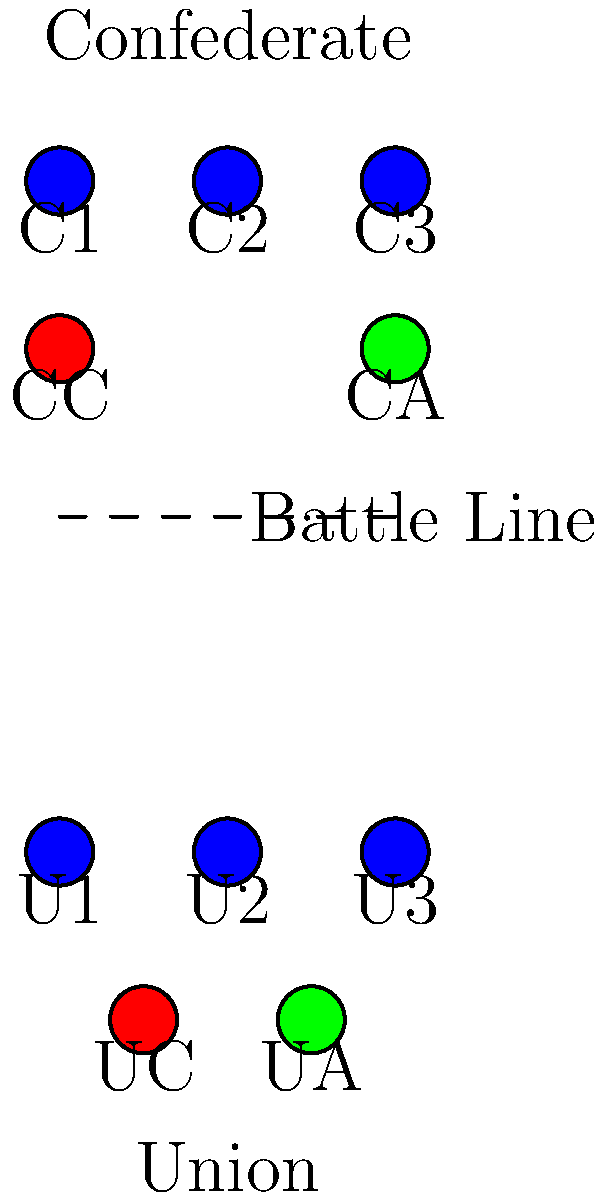In the diagram above, which represents a typical Civil War battle formation, what tactical advantage does the placement of the Union cavalry (UC) provide compared to the Confederate cavalry (CC)? To answer this question, let's analyze the positions of both cavalry units:

1. Union cavalry (UC) placement:
   - Located at the rear of the Union infantry line
   - Positioned between two infantry units (U1 and U2)

2. Confederate cavalry (CC) placement:
   - Located on the left flank of the Confederate infantry line
   - Positioned outside the main line of infantry

3. Tactical advantages of the Union cavalry placement:
   a. Central position: The UC can quickly respond to threats on either flank of the Union line.
   b. Protection: Being behind the infantry line, the UC is less vulnerable to direct attacks.
   c. Flexibility: The UC can be used for counterattacks or to exploit weaknesses in the enemy line.
   d. Support: The UC can provide immediate support to any part of the Union line that needs reinforcement.

4. Limitations of the Confederate cavalry placement:
   a. Limited mobility: The CC is restricted to operations on the left flank.
   b. Vulnerability: Being on the flank, the CC is more exposed to enemy fire and flanking maneuvers.
   c. Reduced ability to support the center and right flank of the Confederate line.

5. Historical context:
   - This formation reflects the evolving role of cavalry in the Civil War, transitioning from shock troops to more flexible, supporting units.
   - The Union's placement demonstrates a more defensive and reactive cavalry strategy, which became more common as the war progressed.

Therefore, the main tactical advantage of the Union cavalry placement is its central position, allowing for greater flexibility and responsiveness across the entire battle line.
Answer: Greater flexibility and responsiveness across the entire battle line 